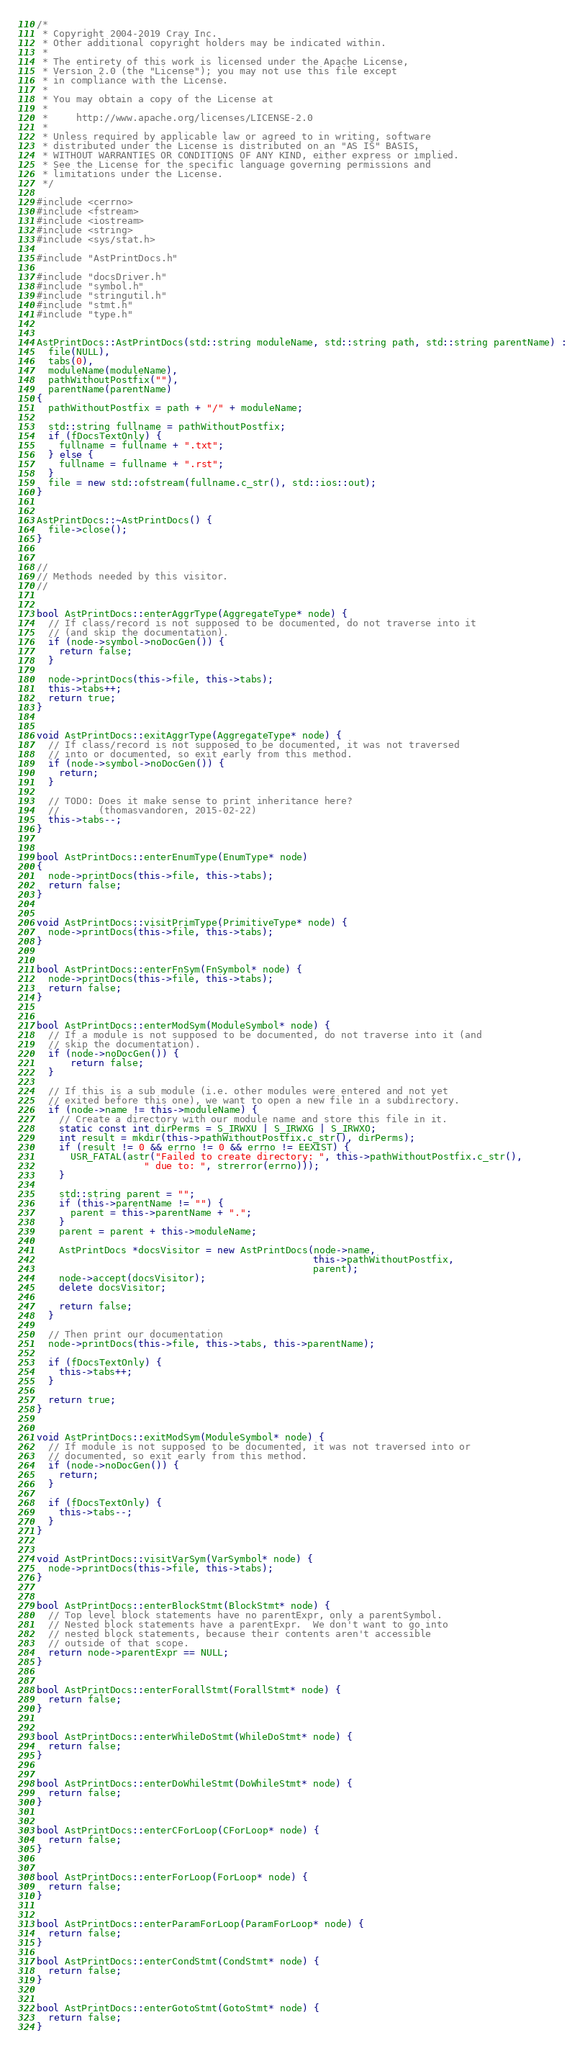<code> <loc_0><loc_0><loc_500><loc_500><_C++_>/*
 * Copyright 2004-2019 Cray Inc.
 * Other additional copyright holders may be indicated within.
 *
 * The entirety of this work is licensed under the Apache License,
 * Version 2.0 (the "License"); you may not use this file except
 * in compliance with the License.
 *
 * You may obtain a copy of the License at
 *
 *     http://www.apache.org/licenses/LICENSE-2.0
 *
 * Unless required by applicable law or agreed to in writing, software
 * distributed under the License is distributed on an "AS IS" BASIS,
 * WITHOUT WARRANTIES OR CONDITIONS OF ANY KIND, either express or implied.
 * See the License for the specific language governing permissions and
 * limitations under the License.
 */

#include <cerrno>
#include <fstream>
#include <iostream>
#include <string>
#include <sys/stat.h>

#include "AstPrintDocs.h"

#include "docsDriver.h"
#include "symbol.h"
#include "stringutil.h"
#include "stmt.h"
#include "type.h"


AstPrintDocs::AstPrintDocs(std::string moduleName, std::string path, std::string parentName) :
  file(NULL),
  tabs(0),
  moduleName(moduleName),
  pathWithoutPostfix(""),
  parentName(parentName)
{
  pathWithoutPostfix = path + "/" + moduleName;

  std::string fullname = pathWithoutPostfix;
  if (fDocsTextOnly) {
    fullname = fullname + ".txt";
  } else {
    fullname = fullname + ".rst";
  }
  file = new std::ofstream(fullname.c_str(), std::ios::out);
}


AstPrintDocs::~AstPrintDocs() {
  file->close();
}


//
// Methods needed by this visitor.
//


bool AstPrintDocs::enterAggrType(AggregateType* node) {
  // If class/record is not supposed to be documented, do not traverse into it
  // (and skip the documentation).
  if (node->symbol->noDocGen()) {
    return false;
  }

  node->printDocs(this->file, this->tabs);
  this->tabs++;
  return true;
}


void AstPrintDocs::exitAggrType(AggregateType* node) {
  // If class/record is not supposed to be documented, it was not traversed
  // into or documented, so exit early from this method.
  if (node->symbol->noDocGen()) {
    return;
  }

  // TODO: Does it make sense to print inheritance here?
  //       (thomasvandoren, 2015-02-22)
  this->tabs--;
}


bool AstPrintDocs::enterEnumType(EnumType* node)
{
  node->printDocs(this->file, this->tabs);
  return false;
}


void AstPrintDocs::visitPrimType(PrimitiveType* node) {
  node->printDocs(this->file, this->tabs);
}


bool AstPrintDocs::enterFnSym(FnSymbol* node) {
  node->printDocs(this->file, this->tabs);
  return false;
}


bool AstPrintDocs::enterModSym(ModuleSymbol* node) {
  // If a module is not supposed to be documented, do not traverse into it (and
  // skip the documentation).
  if (node->noDocGen()) {
      return false;
  }

  // If this is a sub module (i.e. other modules were entered and not yet
  // exited before this one), we want to open a new file in a subdirectory.
  if (node->name != this->moduleName) {
    // Create a directory with our module name and store this file in it.
    static const int dirPerms = S_IRWXU | S_IRWXG | S_IRWXO;
    int result = mkdir(this->pathWithoutPostfix.c_str(), dirPerms);
    if (result != 0 && errno != 0 && errno != EEXIST) {
      USR_FATAL(astr("Failed to create directory: ", this->pathWithoutPostfix.c_str(),
                   " due to: ", strerror(errno)));
    }

    std::string parent = "";
    if (this->parentName != "") {
      parent = this->parentName + ".";
    }
    parent = parent + this->moduleName;

    AstPrintDocs *docsVisitor = new AstPrintDocs(node->name,
                                                 this->pathWithoutPostfix,
                                                 parent);
    node->accept(docsVisitor);
    delete docsVisitor;

    return false;
  }

  // Then print our documentation
  node->printDocs(this->file, this->tabs, this->parentName);

  if (fDocsTextOnly) {
    this->tabs++;
  }

  return true;
}


void AstPrintDocs::exitModSym(ModuleSymbol* node) {
  // If module is not supposed to be documented, it was not traversed into or
  // documented, so exit early from this method.
  if (node->noDocGen()) {
    return;
  }

  if (fDocsTextOnly) {
    this->tabs--;
  }
}


void AstPrintDocs::visitVarSym(VarSymbol* node) {
  node->printDocs(this->file, this->tabs);
}


bool AstPrintDocs::enterBlockStmt(BlockStmt* node) {
  // Top level block statements have no parentExpr, only a parentSymbol.
  // Nested block statements have a parentExpr.  We don't want to go into
  // nested block statements, because their contents aren't accessible
  // outside of that scope.
  return node->parentExpr == NULL;
}


bool AstPrintDocs::enterForallStmt(ForallStmt* node) {
  return false;
}


bool AstPrintDocs::enterWhileDoStmt(WhileDoStmt* node) {
  return false;
}


bool AstPrintDocs::enterDoWhileStmt(DoWhileStmt* node) {
  return false;
}


bool AstPrintDocs::enterCForLoop(CForLoop* node) {
  return false;
}


bool AstPrintDocs::enterForLoop(ForLoop* node) {
  return false;
}


bool AstPrintDocs::enterParamForLoop(ParamForLoop* node) {
  return false;
}

bool AstPrintDocs::enterCondStmt(CondStmt* node) {
  return false;
}


bool AstPrintDocs::enterGotoStmt(GotoStmt* node) {
  return false;
}
</code> 